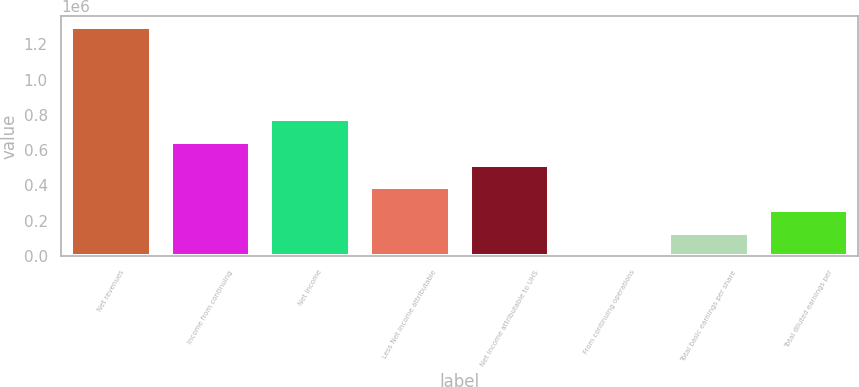Convert chart to OTSL. <chart><loc_0><loc_0><loc_500><loc_500><bar_chart><fcel>Net revenues<fcel>Income from continuing<fcel>Net income<fcel>Less Net income attributable<fcel>Net income attributable to UHS<fcel>From continuing operations<fcel>Total basic earnings per share<fcel>Total diluted earnings per<nl><fcel>1.29511e+06<fcel>647555<fcel>777066<fcel>388533<fcel>518044<fcel>0.52<fcel>129511<fcel>259022<nl></chart> 